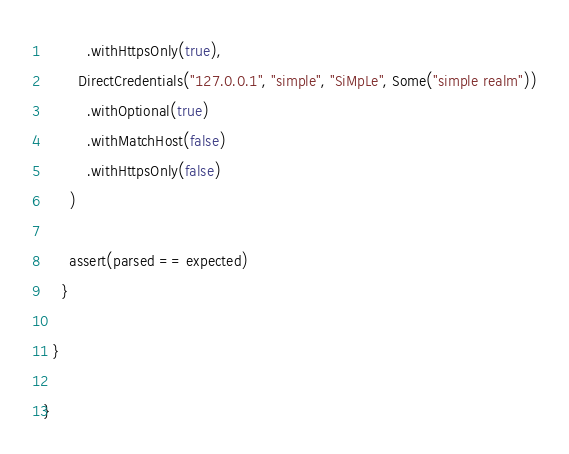Convert code to text. <code><loc_0><loc_0><loc_500><loc_500><_Scala_>          .withHttpsOnly(true),
        DirectCredentials("127.0.0.1", "simple", "SiMpLe", Some("simple realm"))
          .withOptional(true)
          .withMatchHost(false)
          .withHttpsOnly(false)
      )

      assert(parsed == expected)
    }

  }

}
</code> 